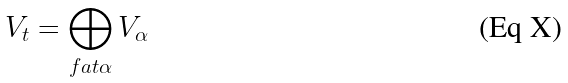<formula> <loc_0><loc_0><loc_500><loc_500>V _ { t } = \bigoplus _ { f a t \alpha } V _ { \alpha }</formula> 